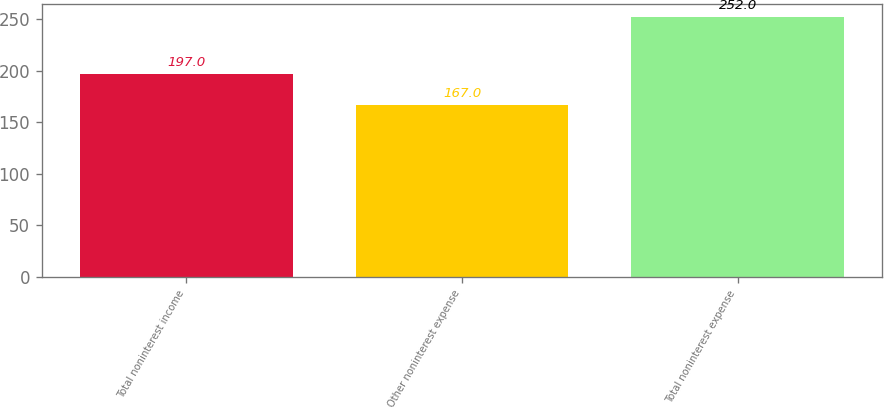Convert chart. <chart><loc_0><loc_0><loc_500><loc_500><bar_chart><fcel>Total noninterest income<fcel>Other noninterest expense<fcel>Total noninterest expense<nl><fcel>197<fcel>167<fcel>252<nl></chart> 